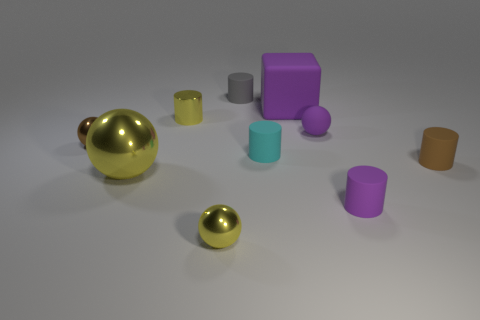How big is the cylinder that is behind the yellow metal cylinder?
Your answer should be very brief. Small. What number of purple objects are either matte cubes or matte spheres?
Your answer should be very brief. 2. Are there any other things that have the same material as the big yellow object?
Offer a very short reply. Yes. What is the material of the brown thing that is the same shape as the large yellow thing?
Provide a short and direct response. Metal. Are there the same number of tiny things left of the tiny yellow metal cylinder and large shiny objects?
Your answer should be very brief. Yes. What is the size of the matte cylinder that is both in front of the small brown sphere and behind the brown cylinder?
Provide a succinct answer. Small. Are there any other things of the same color as the large shiny thing?
Your response must be concise. Yes. What size is the cylinder that is behind the big purple cube that is on the left side of the tiny brown cylinder?
Give a very brief answer. Small. There is a rubber cylinder that is on the left side of the large rubber thing and in front of the purple block; what is its color?
Keep it short and to the point. Cyan. What number of other objects are the same size as the yellow cylinder?
Give a very brief answer. 7. 